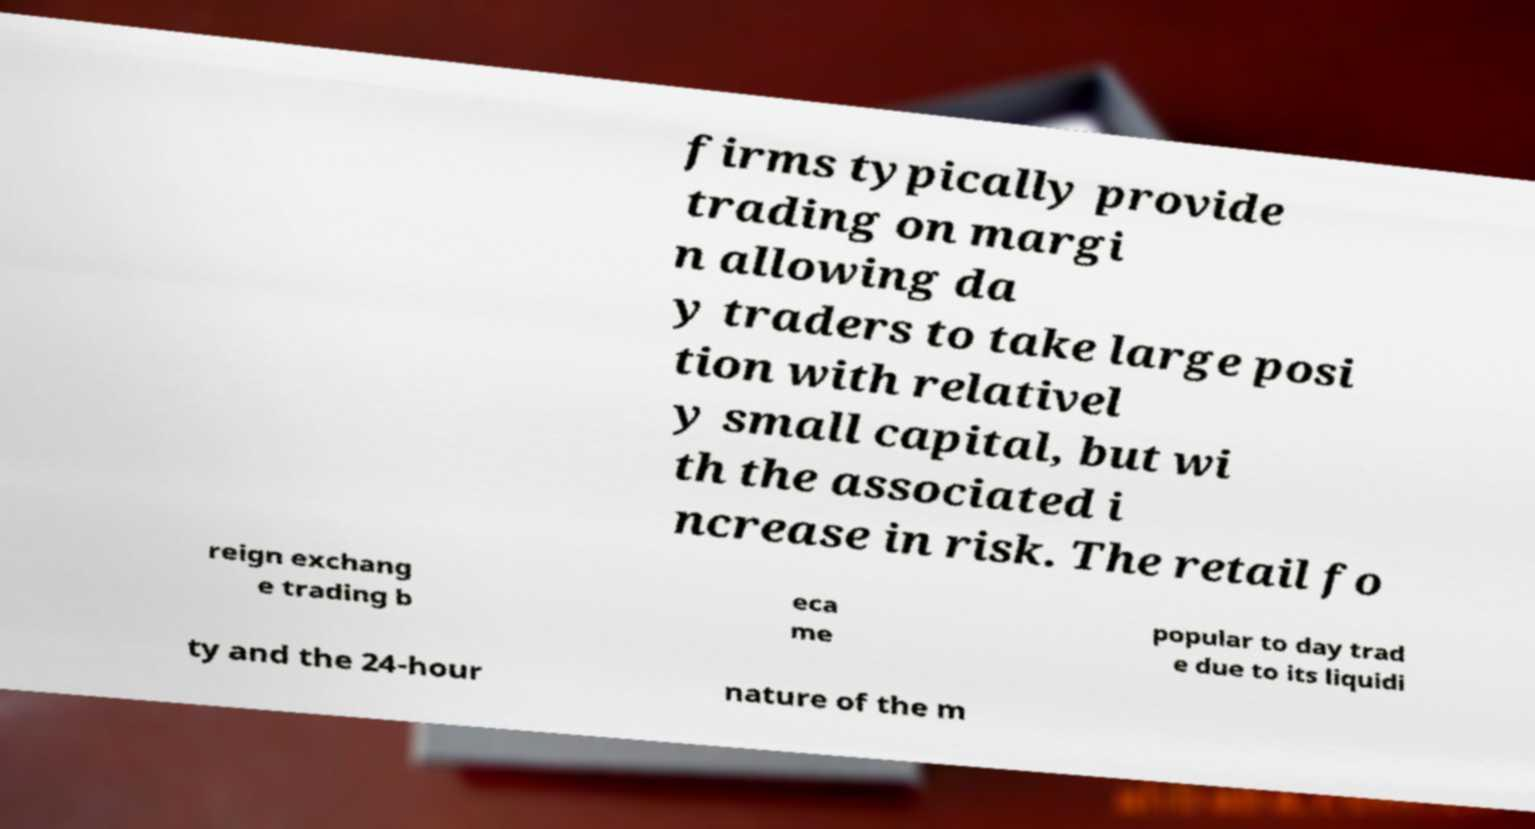Please read and relay the text visible in this image. What does it say? firms typically provide trading on margi n allowing da y traders to take large posi tion with relativel y small capital, but wi th the associated i ncrease in risk. The retail fo reign exchang e trading b eca me popular to day trad e due to its liquidi ty and the 24-hour nature of the m 